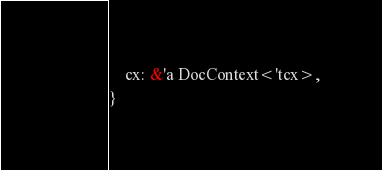<code> <loc_0><loc_0><loc_500><loc_500><_Rust_>    cx: &'a DocContext<'tcx>,
}
</code> 